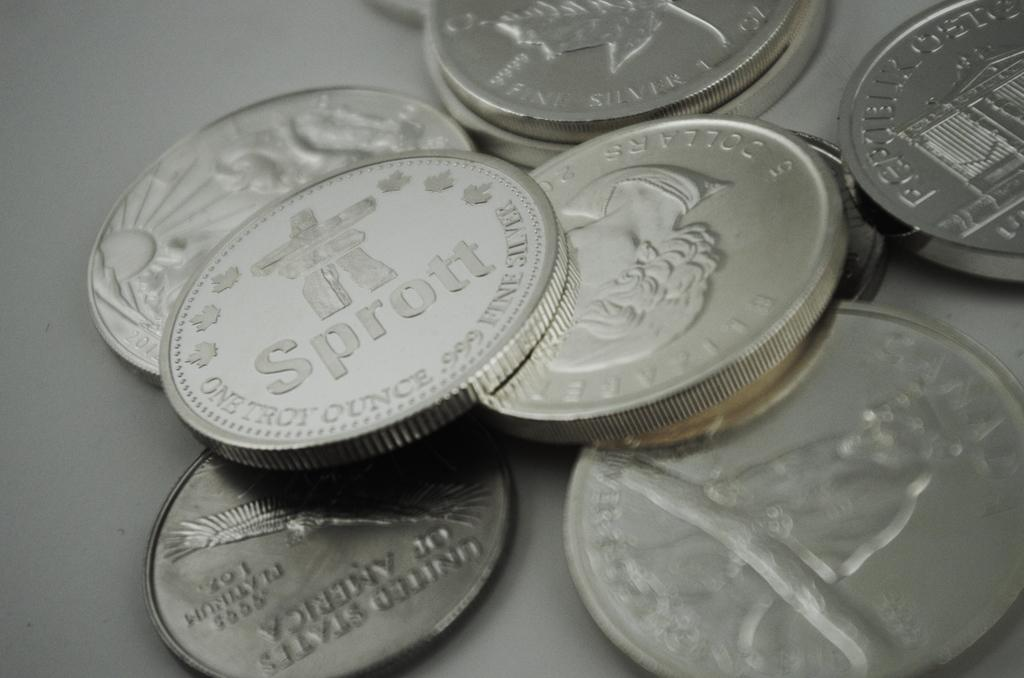What piece of furniture is present in the image? There is a table in the image. What objects are on the table? There are coins on the table. How many girls are sitting on the table with the coins? There are no girls present in the image; it only shows a table with coins on it. What type of bird can be seen flying over the table? There is no bird present in the image; it only shows a table with coins on it. 